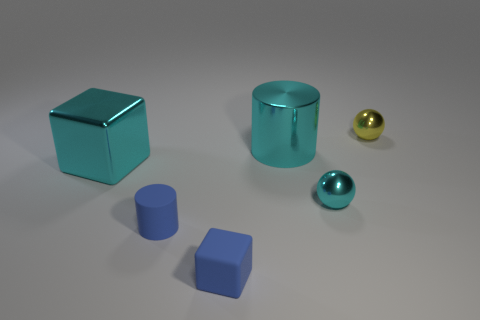Do the big cylinder and the big shiny cube have the same color?
Provide a short and direct response. Yes. There is a shiny cylinder that is the same color as the large block; what is its size?
Offer a terse response. Large. There is a shiny object that is to the right of the tiny cyan ball; is its shape the same as the tiny cyan metal thing?
Your answer should be very brief. Yes. Are there more blue blocks that are to the right of the big cyan block than small blue matte cubes that are in front of the blue cube?
Give a very brief answer. Yes. There is a thing left of the tiny blue rubber cylinder; how many tiny rubber things are behind it?
Make the answer very short. 0. What is the material of the small thing that is the same color as the large metallic cylinder?
Give a very brief answer. Metal. How many other objects are the same color as the big metal block?
Make the answer very short. 2. The large object to the left of the big metal cylinder to the right of the cyan block is what color?
Give a very brief answer. Cyan. Are there any tiny rubber cylinders of the same color as the shiny cylinder?
Your response must be concise. No. How many rubber things are blue cylinders or tiny cyan cubes?
Your answer should be compact. 1. 